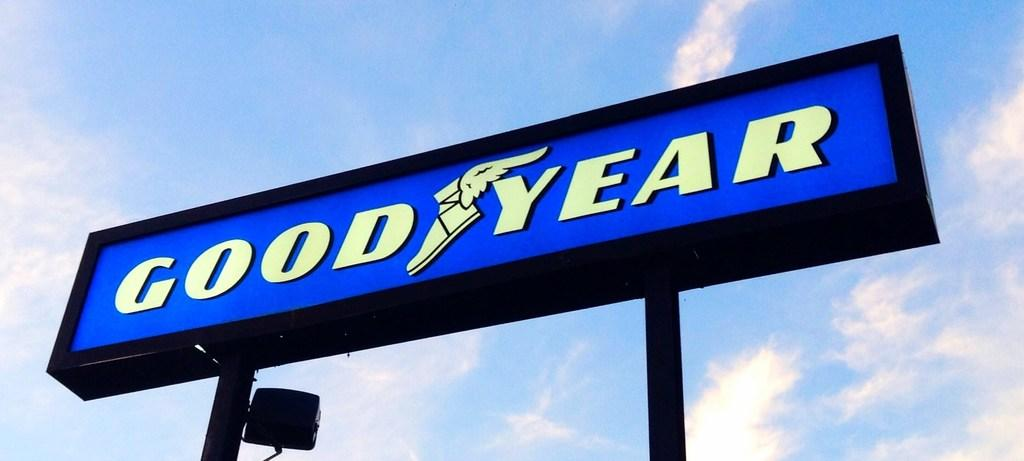Provide a one-sentence caption for the provided image. a sign that has the word Goodyear on it. 